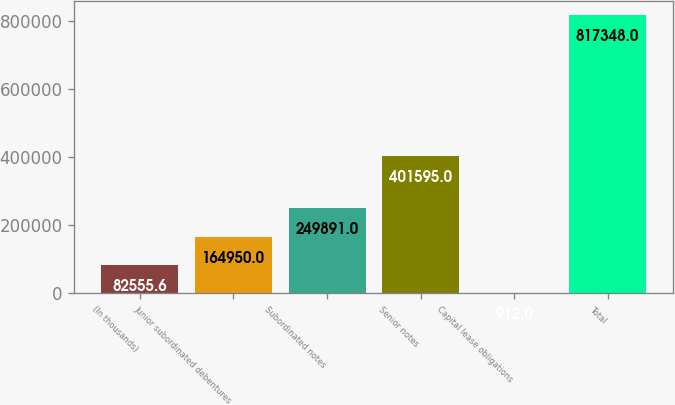<chart> <loc_0><loc_0><loc_500><loc_500><bar_chart><fcel>(In thousands)<fcel>Junior subordinated debentures<fcel>Subordinated notes<fcel>Senior notes<fcel>Capital lease obligations<fcel>Total<nl><fcel>82555.6<fcel>164950<fcel>249891<fcel>401595<fcel>912<fcel>817348<nl></chart> 